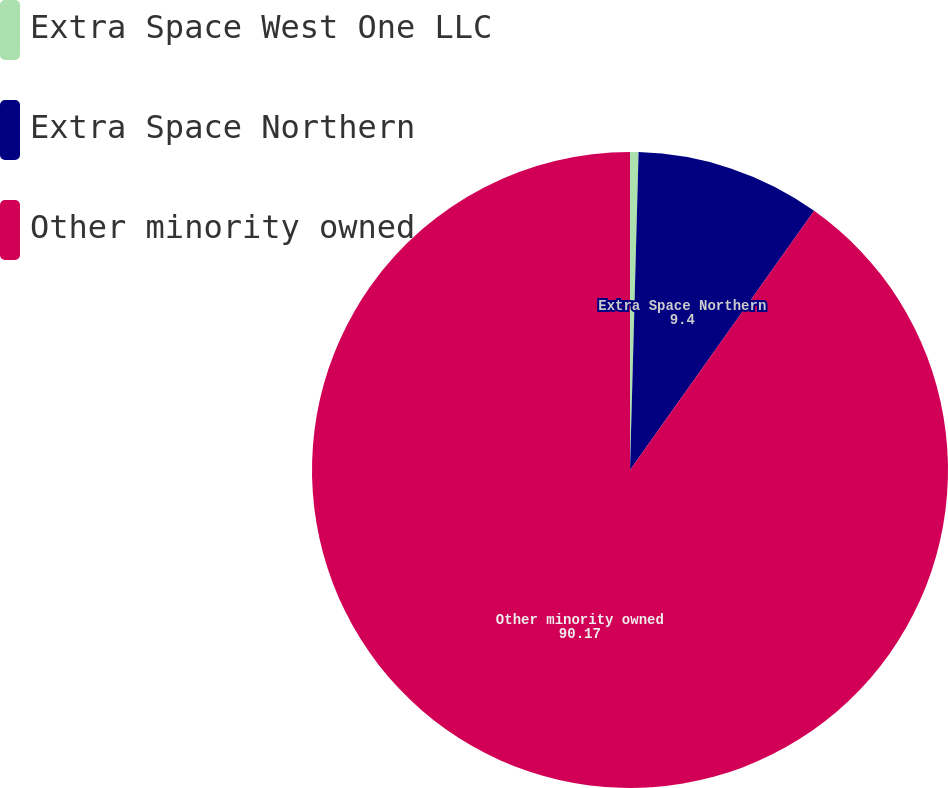<chart> <loc_0><loc_0><loc_500><loc_500><pie_chart><fcel>Extra Space West One LLC<fcel>Extra Space Northern<fcel>Other minority owned<nl><fcel>0.43%<fcel>9.4%<fcel>90.17%<nl></chart> 